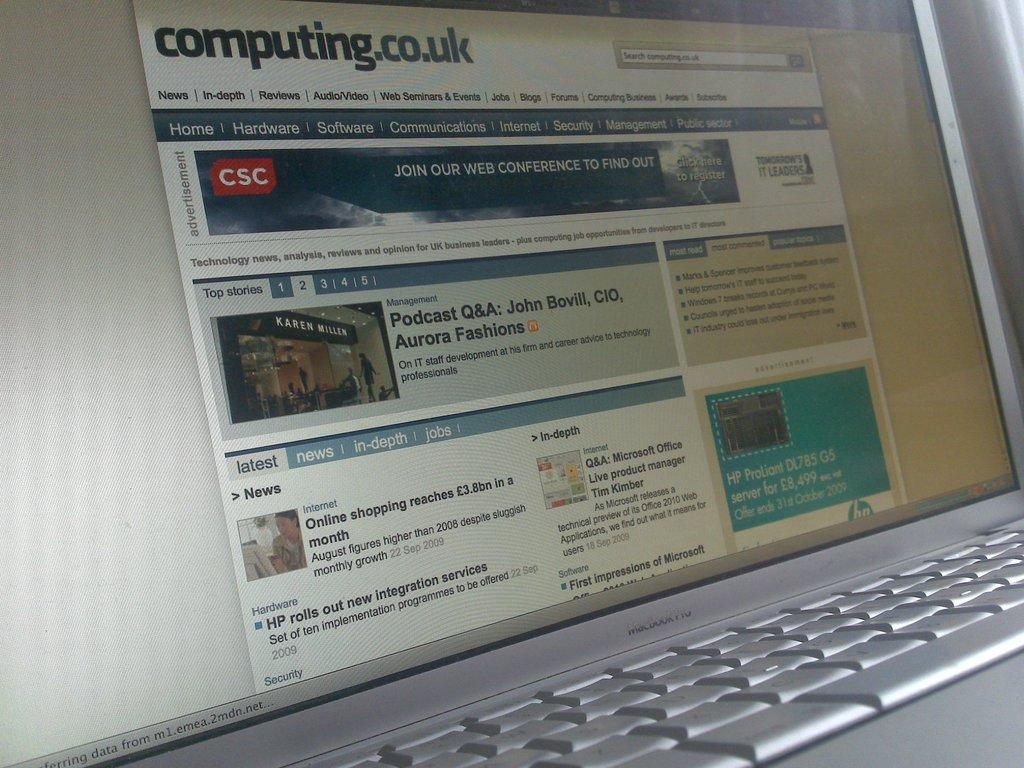<image>
Describe the image concisely. A laptop with the website "computing.co.uk" on it. 